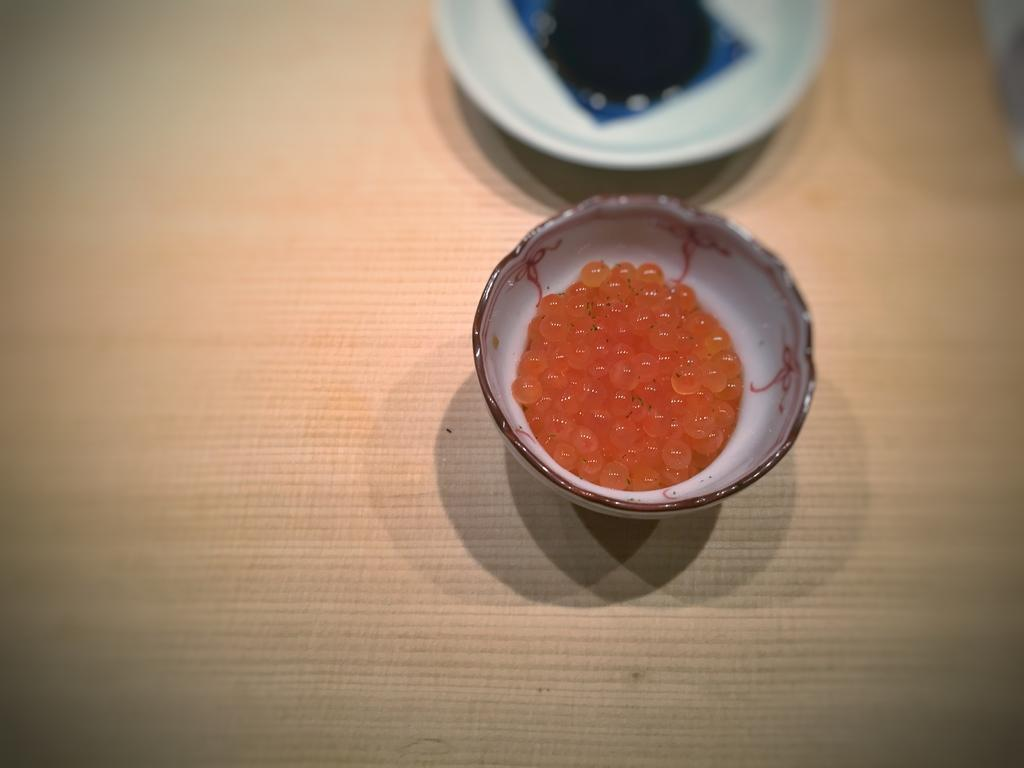What is the size of the bowl in the image? The bowl in the image is small. What other object is present on the table in the image? There is a plate on the table in the image. Where are the bowl and the plate located in the image? Both the bowl and the plate are on a table in the image. Can you see a bee buzzing around the bowl in the image? No, there is no bee present in the image. What type of crook might be associated with the plate in the image? There is no crook present in the image, and the plate does not have any specific association with a crook. 